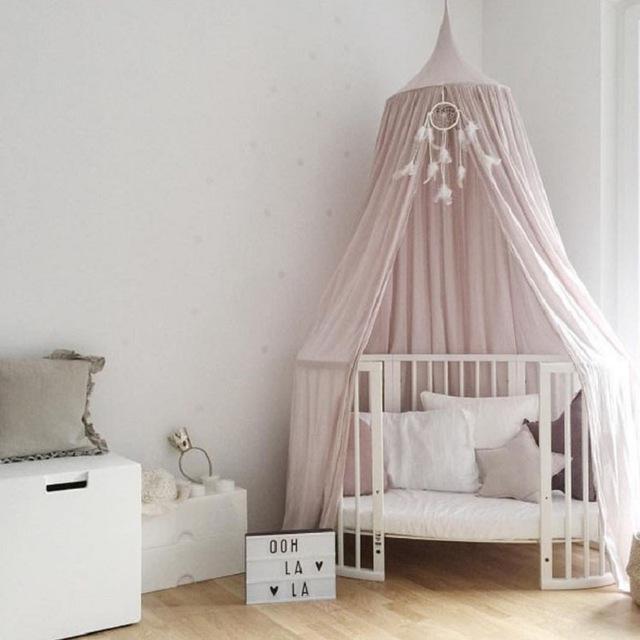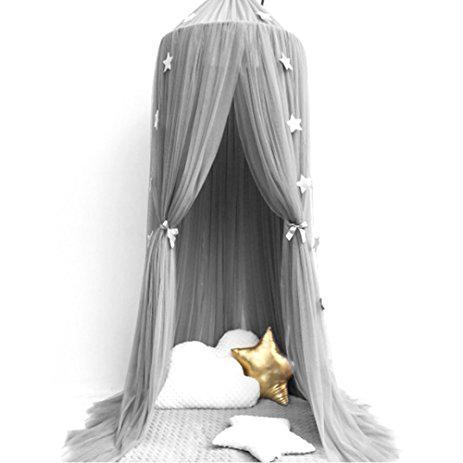The first image is the image on the left, the second image is the image on the right. For the images shown, is this caption "The right image shows a gauzy light gray canopy with a garland of stars hung from the ceiling over a toddler bed with vertical bars and a chair with a plant on its seat next to it." true? Answer yes or no. No. 